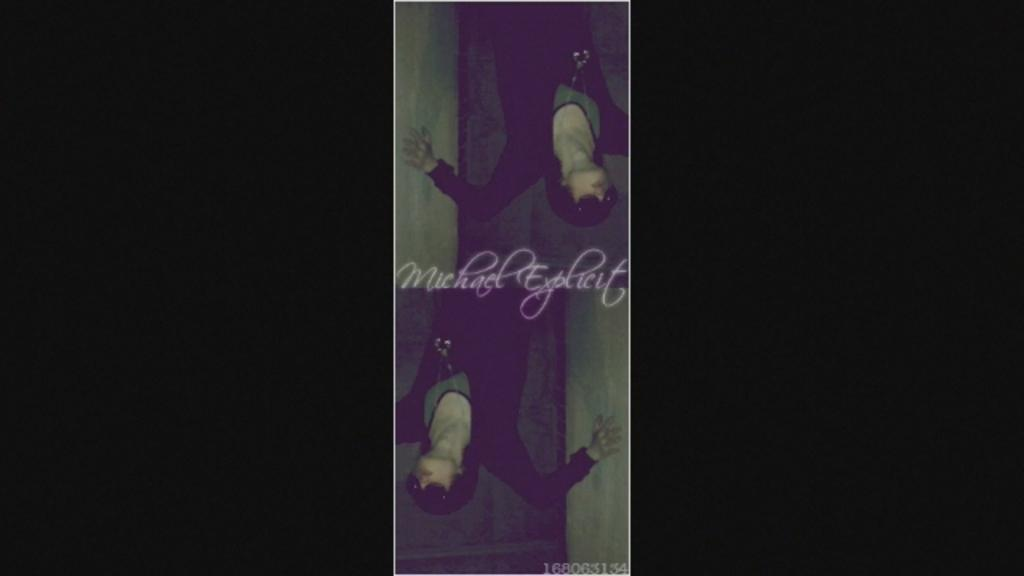What type of artwork is the image? The image is a collage. Who or what is depicted in the collage? The collage features a lady. What is located at the center of the image? There is text at the center of the image. What type of pies can be seen in the image? There are no pies present in the image; it is a collage featuring a lady with text at the center. Is there a gate visible in the image? There is no gate present in the image. 